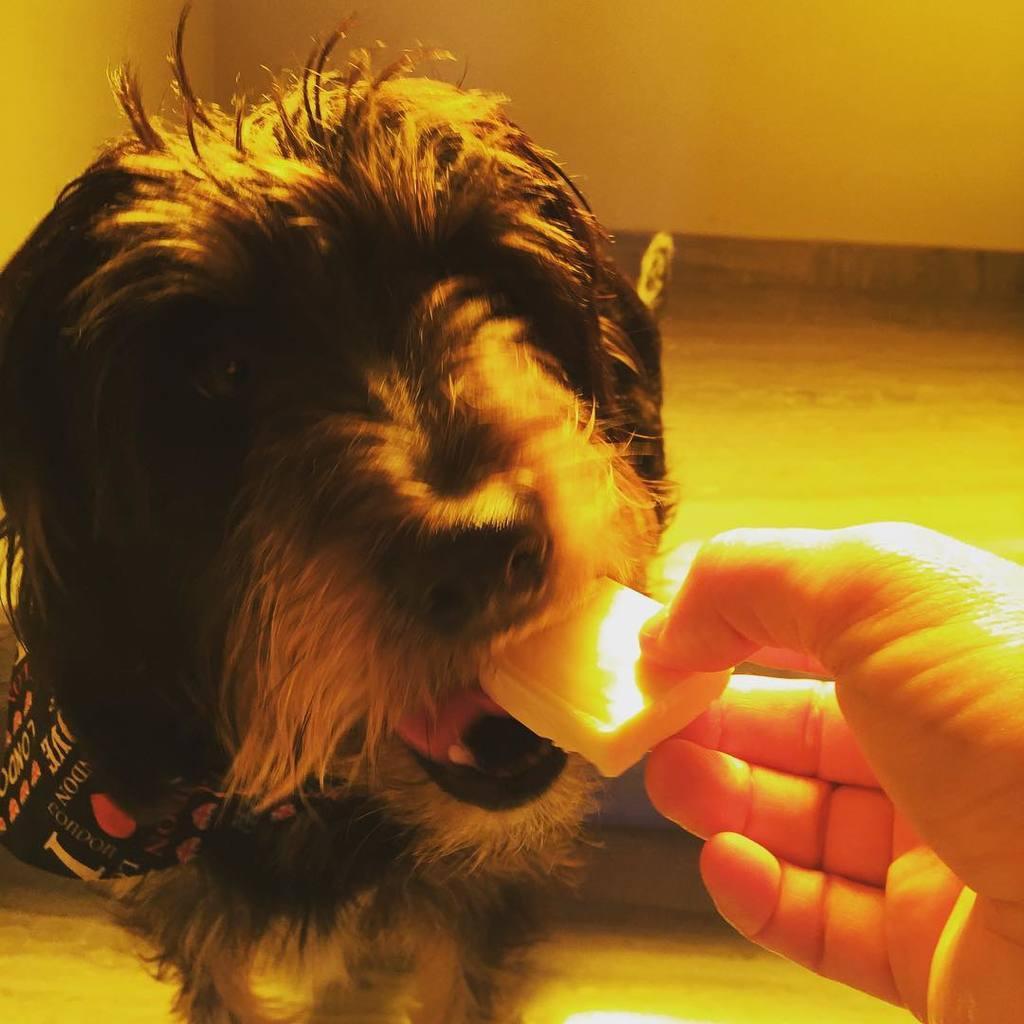How would you summarize this image in a sentence or two? In this image there is a dog sitting on the floor. Right side a person's hand is visible. He is holding some food and he is feeding the dog. Background there is a wall. 